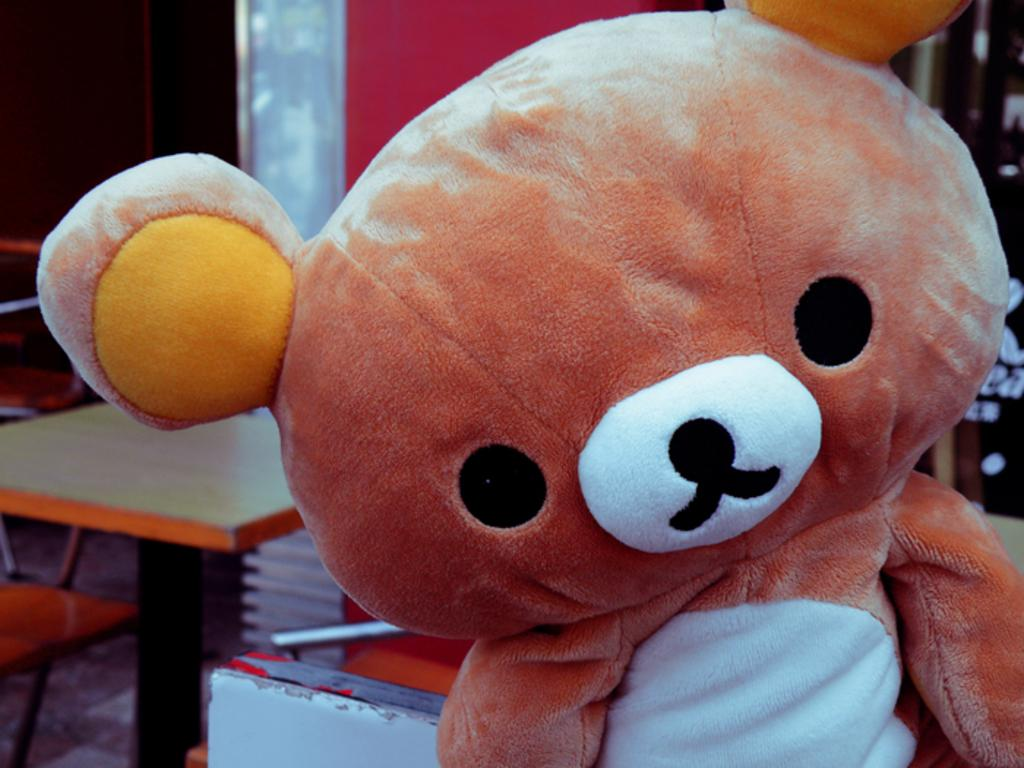What is located on the right side of the image? There is a doll on the right side of the image. What can be seen in the background of the image? There is a wall, a table, and chairs in the background of the image. What type of surface is visible in the image? There is a floor visible in the image. How many giraffes are present in the image? There are no giraffes present in the image. What is the amount of monkeys visible in the image? There are no monkeys visible in the image. 